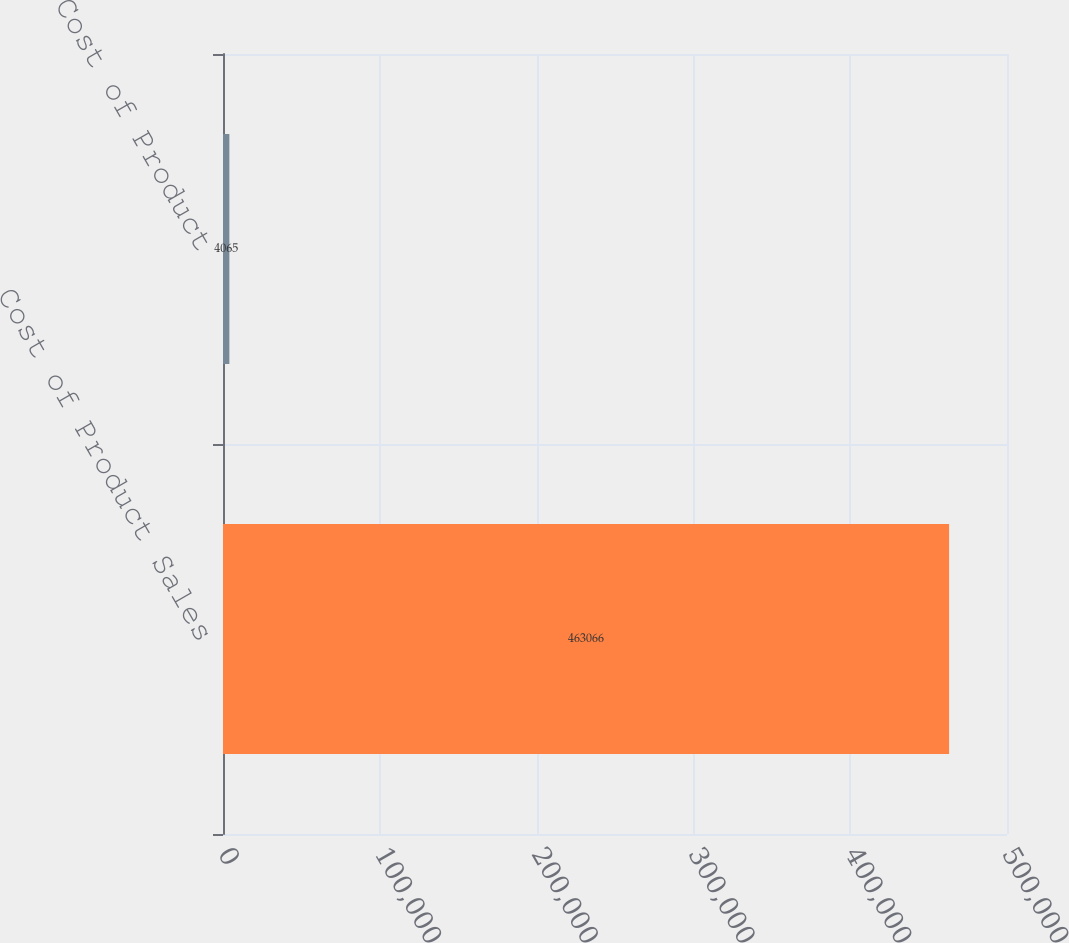Convert chart. <chart><loc_0><loc_0><loc_500><loc_500><bar_chart><fcel>Cost of Product Sales<fcel>Cost of Product<nl><fcel>463066<fcel>4065<nl></chart> 